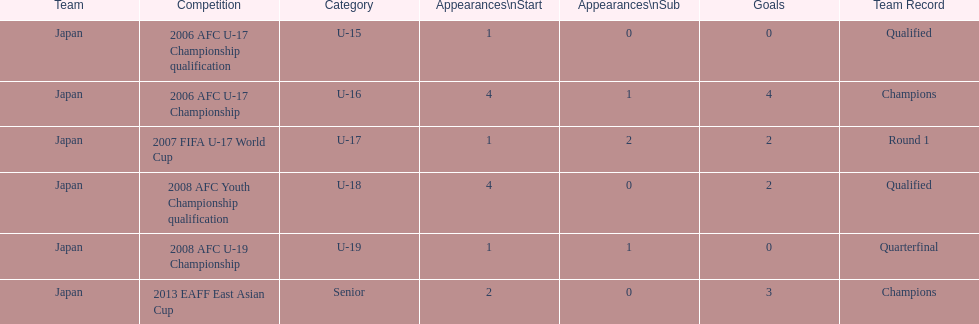Which competition had the highest number of starts and goals? 2006 AFC U-17 Championship. 